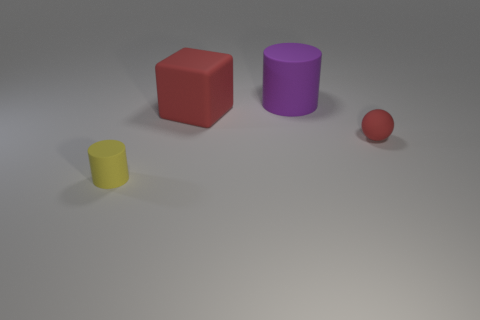Add 2 rubber blocks. How many objects exist? 6 Subtract all blocks. How many objects are left? 3 Add 2 small red matte balls. How many small red matte balls exist? 3 Subtract 0 blue blocks. How many objects are left? 4 Subtract all yellow matte objects. Subtract all large objects. How many objects are left? 1 Add 1 yellow objects. How many yellow objects are left? 2 